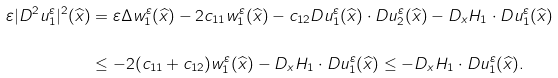Convert formula to latex. <formula><loc_0><loc_0><loc_500><loc_500>\varepsilon | D ^ { 2 } u ^ { \varepsilon } _ { 1 } | ^ { 2 } ( \widehat { x } ) & = \varepsilon \Delta w ^ { \varepsilon } _ { 1 } ( \widehat { x } ) - 2 c _ { 1 1 } w ^ { \varepsilon } _ { 1 } ( \widehat { x } ) - c _ { 1 2 } D u ^ { \varepsilon } _ { 1 } ( \widehat { x } ) \cdot D u ^ { \varepsilon } _ { 2 } ( \widehat { x } ) - D _ { x } H _ { 1 } \cdot D u ^ { \varepsilon } _ { 1 } ( \widehat { x } ) \\ & \leq - 2 ( c _ { 1 1 } + c _ { 1 2 } ) w ^ { \varepsilon } _ { 1 } ( \widehat { x } ) - D _ { x } H _ { 1 } \cdot D u ^ { \varepsilon } _ { 1 } ( \widehat { x } ) \leq - D _ { x } H _ { 1 } \cdot D u ^ { \varepsilon } _ { 1 } ( \widehat { x } ) .</formula> 